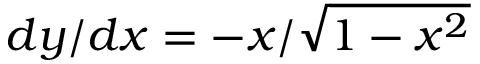<formula> <loc_0><loc_0><loc_500><loc_500>d y / d x = - x / { \sqrt { 1 - x ^ { 2 } } }</formula> 